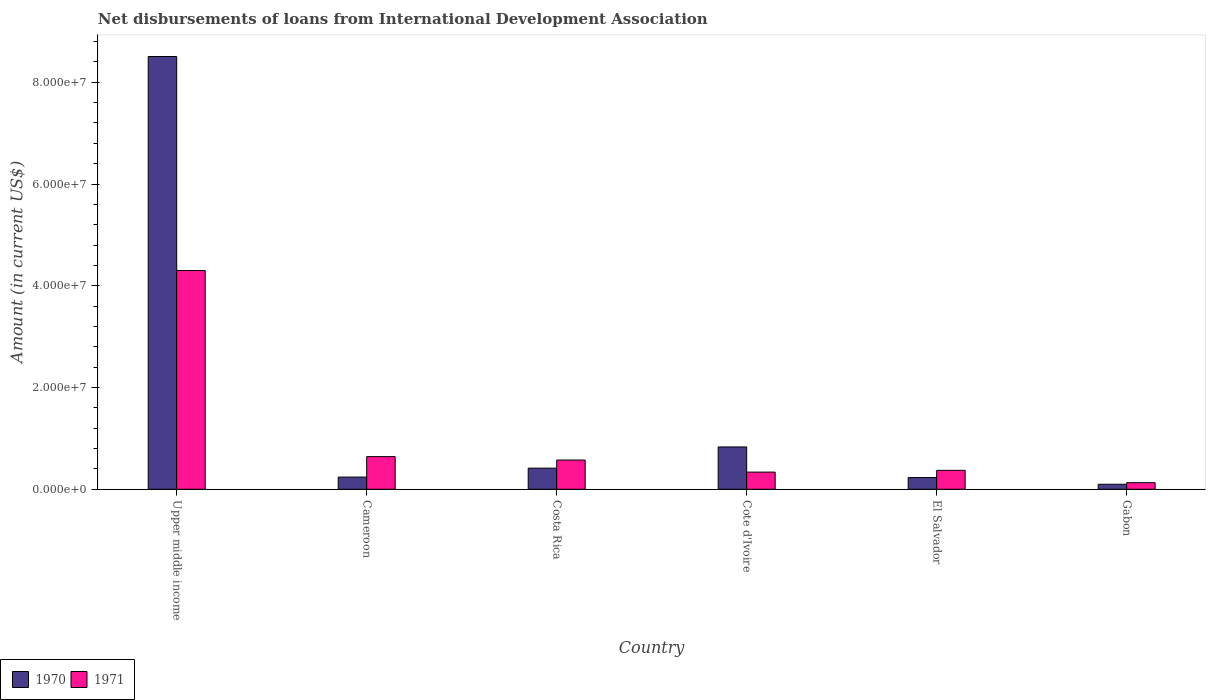How many groups of bars are there?
Provide a short and direct response. 6. Are the number of bars per tick equal to the number of legend labels?
Make the answer very short. Yes. Are the number of bars on each tick of the X-axis equal?
Give a very brief answer. Yes. How many bars are there on the 3rd tick from the left?
Keep it short and to the point. 2. How many bars are there on the 5th tick from the right?
Ensure brevity in your answer.  2. What is the label of the 5th group of bars from the left?
Ensure brevity in your answer.  El Salvador. In how many cases, is the number of bars for a given country not equal to the number of legend labels?
Provide a succinct answer. 0. What is the amount of loans disbursed in 1971 in Costa Rica?
Offer a terse response. 5.74e+06. Across all countries, what is the maximum amount of loans disbursed in 1970?
Your answer should be very brief. 8.51e+07. Across all countries, what is the minimum amount of loans disbursed in 1971?
Ensure brevity in your answer.  1.30e+06. In which country was the amount of loans disbursed in 1970 maximum?
Offer a terse response. Upper middle income. In which country was the amount of loans disbursed in 1970 minimum?
Give a very brief answer. Gabon. What is the total amount of loans disbursed in 1970 in the graph?
Your answer should be very brief. 1.03e+08. What is the difference between the amount of loans disbursed in 1971 in Cote d'Ivoire and that in El Salvador?
Ensure brevity in your answer.  -3.50e+05. What is the difference between the amount of loans disbursed in 1971 in Upper middle income and the amount of loans disbursed in 1970 in Gabon?
Offer a terse response. 4.20e+07. What is the average amount of loans disbursed in 1971 per country?
Provide a succinct answer. 1.06e+07. What is the difference between the amount of loans disbursed of/in 1970 and amount of loans disbursed of/in 1971 in Cote d'Ivoire?
Make the answer very short. 4.95e+06. In how many countries, is the amount of loans disbursed in 1970 greater than 76000000 US$?
Offer a very short reply. 1. What is the ratio of the amount of loans disbursed in 1971 in Costa Rica to that in Upper middle income?
Your response must be concise. 0.13. Is the amount of loans disbursed in 1970 in El Salvador less than that in Upper middle income?
Your response must be concise. Yes. Is the difference between the amount of loans disbursed in 1970 in Cote d'Ivoire and Upper middle income greater than the difference between the amount of loans disbursed in 1971 in Cote d'Ivoire and Upper middle income?
Your response must be concise. No. What is the difference between the highest and the second highest amount of loans disbursed in 1971?
Your answer should be very brief. 3.66e+07. What is the difference between the highest and the lowest amount of loans disbursed in 1970?
Your response must be concise. 8.41e+07. In how many countries, is the amount of loans disbursed in 1970 greater than the average amount of loans disbursed in 1970 taken over all countries?
Offer a very short reply. 1. Is the sum of the amount of loans disbursed in 1970 in Cote d'Ivoire and El Salvador greater than the maximum amount of loans disbursed in 1971 across all countries?
Make the answer very short. No. What does the 2nd bar from the left in Gabon represents?
Offer a very short reply. 1971. How many bars are there?
Your answer should be compact. 12. Are the values on the major ticks of Y-axis written in scientific E-notation?
Offer a terse response. Yes. Does the graph contain any zero values?
Give a very brief answer. No. Where does the legend appear in the graph?
Your response must be concise. Bottom left. What is the title of the graph?
Keep it short and to the point. Net disbursements of loans from International Development Association. What is the label or title of the Y-axis?
Provide a short and direct response. Amount (in current US$). What is the Amount (in current US$) of 1970 in Upper middle income?
Make the answer very short. 8.51e+07. What is the Amount (in current US$) in 1971 in Upper middle income?
Provide a succinct answer. 4.30e+07. What is the Amount (in current US$) in 1970 in Cameroon?
Make the answer very short. 2.40e+06. What is the Amount (in current US$) of 1971 in Cameroon?
Your answer should be very brief. 6.42e+06. What is the Amount (in current US$) of 1970 in Costa Rica?
Offer a very short reply. 4.15e+06. What is the Amount (in current US$) of 1971 in Costa Rica?
Your answer should be compact. 5.74e+06. What is the Amount (in current US$) of 1970 in Cote d'Ivoire?
Your response must be concise. 8.32e+06. What is the Amount (in current US$) in 1971 in Cote d'Ivoire?
Keep it short and to the point. 3.37e+06. What is the Amount (in current US$) in 1970 in El Salvador?
Make the answer very short. 2.30e+06. What is the Amount (in current US$) in 1971 in El Salvador?
Provide a short and direct response. 3.72e+06. What is the Amount (in current US$) in 1970 in Gabon?
Give a very brief answer. 9.85e+05. What is the Amount (in current US$) of 1971 in Gabon?
Make the answer very short. 1.30e+06. Across all countries, what is the maximum Amount (in current US$) of 1970?
Ensure brevity in your answer.  8.51e+07. Across all countries, what is the maximum Amount (in current US$) of 1971?
Make the answer very short. 4.30e+07. Across all countries, what is the minimum Amount (in current US$) in 1970?
Provide a short and direct response. 9.85e+05. Across all countries, what is the minimum Amount (in current US$) in 1971?
Give a very brief answer. 1.30e+06. What is the total Amount (in current US$) of 1970 in the graph?
Your answer should be compact. 1.03e+08. What is the total Amount (in current US$) of 1971 in the graph?
Make the answer very short. 6.36e+07. What is the difference between the Amount (in current US$) of 1970 in Upper middle income and that in Cameroon?
Your answer should be very brief. 8.27e+07. What is the difference between the Amount (in current US$) in 1971 in Upper middle income and that in Cameroon?
Keep it short and to the point. 3.66e+07. What is the difference between the Amount (in current US$) in 1970 in Upper middle income and that in Costa Rica?
Ensure brevity in your answer.  8.09e+07. What is the difference between the Amount (in current US$) in 1971 in Upper middle income and that in Costa Rica?
Offer a terse response. 3.73e+07. What is the difference between the Amount (in current US$) of 1970 in Upper middle income and that in Cote d'Ivoire?
Offer a terse response. 7.67e+07. What is the difference between the Amount (in current US$) in 1971 in Upper middle income and that in Cote d'Ivoire?
Ensure brevity in your answer.  3.96e+07. What is the difference between the Amount (in current US$) in 1970 in Upper middle income and that in El Salvador?
Provide a succinct answer. 8.28e+07. What is the difference between the Amount (in current US$) of 1971 in Upper middle income and that in El Salvador?
Offer a terse response. 3.93e+07. What is the difference between the Amount (in current US$) of 1970 in Upper middle income and that in Gabon?
Keep it short and to the point. 8.41e+07. What is the difference between the Amount (in current US$) of 1971 in Upper middle income and that in Gabon?
Ensure brevity in your answer.  4.17e+07. What is the difference between the Amount (in current US$) in 1970 in Cameroon and that in Costa Rica?
Keep it short and to the point. -1.76e+06. What is the difference between the Amount (in current US$) of 1971 in Cameroon and that in Costa Rica?
Provide a short and direct response. 6.75e+05. What is the difference between the Amount (in current US$) in 1970 in Cameroon and that in Cote d'Ivoire?
Ensure brevity in your answer.  -5.92e+06. What is the difference between the Amount (in current US$) of 1971 in Cameroon and that in Cote d'Ivoire?
Your answer should be very brief. 3.04e+06. What is the difference between the Amount (in current US$) of 1970 in Cameroon and that in El Salvador?
Your answer should be compact. 9.30e+04. What is the difference between the Amount (in current US$) of 1971 in Cameroon and that in El Salvador?
Make the answer very short. 2.70e+06. What is the difference between the Amount (in current US$) of 1970 in Cameroon and that in Gabon?
Keep it short and to the point. 1.41e+06. What is the difference between the Amount (in current US$) in 1971 in Cameroon and that in Gabon?
Offer a very short reply. 5.12e+06. What is the difference between the Amount (in current US$) in 1970 in Costa Rica and that in Cote d'Ivoire?
Ensure brevity in your answer.  -4.17e+06. What is the difference between the Amount (in current US$) in 1971 in Costa Rica and that in Cote d'Ivoire?
Your answer should be very brief. 2.37e+06. What is the difference between the Amount (in current US$) of 1970 in Costa Rica and that in El Salvador?
Offer a very short reply. 1.85e+06. What is the difference between the Amount (in current US$) in 1971 in Costa Rica and that in El Salvador?
Offer a terse response. 2.02e+06. What is the difference between the Amount (in current US$) in 1970 in Costa Rica and that in Gabon?
Provide a short and direct response. 3.17e+06. What is the difference between the Amount (in current US$) of 1971 in Costa Rica and that in Gabon?
Your answer should be compact. 4.45e+06. What is the difference between the Amount (in current US$) of 1970 in Cote d'Ivoire and that in El Salvador?
Provide a short and direct response. 6.02e+06. What is the difference between the Amount (in current US$) of 1971 in Cote d'Ivoire and that in El Salvador?
Keep it short and to the point. -3.50e+05. What is the difference between the Amount (in current US$) of 1970 in Cote d'Ivoire and that in Gabon?
Offer a terse response. 7.34e+06. What is the difference between the Amount (in current US$) in 1971 in Cote d'Ivoire and that in Gabon?
Keep it short and to the point. 2.08e+06. What is the difference between the Amount (in current US$) in 1970 in El Salvador and that in Gabon?
Make the answer very short. 1.32e+06. What is the difference between the Amount (in current US$) in 1971 in El Salvador and that in Gabon?
Keep it short and to the point. 2.43e+06. What is the difference between the Amount (in current US$) of 1970 in Upper middle income and the Amount (in current US$) of 1971 in Cameroon?
Make the answer very short. 7.86e+07. What is the difference between the Amount (in current US$) in 1970 in Upper middle income and the Amount (in current US$) in 1971 in Costa Rica?
Ensure brevity in your answer.  7.93e+07. What is the difference between the Amount (in current US$) in 1970 in Upper middle income and the Amount (in current US$) in 1971 in Cote d'Ivoire?
Your response must be concise. 8.17e+07. What is the difference between the Amount (in current US$) of 1970 in Upper middle income and the Amount (in current US$) of 1971 in El Salvador?
Your response must be concise. 8.13e+07. What is the difference between the Amount (in current US$) of 1970 in Upper middle income and the Amount (in current US$) of 1971 in Gabon?
Offer a very short reply. 8.38e+07. What is the difference between the Amount (in current US$) in 1970 in Cameroon and the Amount (in current US$) in 1971 in Costa Rica?
Your answer should be very brief. -3.35e+06. What is the difference between the Amount (in current US$) of 1970 in Cameroon and the Amount (in current US$) of 1971 in Cote d'Ivoire?
Offer a very short reply. -9.78e+05. What is the difference between the Amount (in current US$) in 1970 in Cameroon and the Amount (in current US$) in 1971 in El Salvador?
Offer a very short reply. -1.33e+06. What is the difference between the Amount (in current US$) in 1970 in Cameroon and the Amount (in current US$) in 1971 in Gabon?
Make the answer very short. 1.10e+06. What is the difference between the Amount (in current US$) in 1970 in Costa Rica and the Amount (in current US$) in 1971 in Cote d'Ivoire?
Offer a terse response. 7.79e+05. What is the difference between the Amount (in current US$) of 1970 in Costa Rica and the Amount (in current US$) of 1971 in El Salvador?
Make the answer very short. 4.29e+05. What is the difference between the Amount (in current US$) in 1970 in Costa Rica and the Amount (in current US$) in 1971 in Gabon?
Offer a very short reply. 2.86e+06. What is the difference between the Amount (in current US$) in 1970 in Cote d'Ivoire and the Amount (in current US$) in 1971 in El Salvador?
Offer a very short reply. 4.60e+06. What is the difference between the Amount (in current US$) of 1970 in Cote d'Ivoire and the Amount (in current US$) of 1971 in Gabon?
Give a very brief answer. 7.02e+06. What is the difference between the Amount (in current US$) of 1970 in El Salvador and the Amount (in current US$) of 1971 in Gabon?
Offer a terse response. 1.01e+06. What is the average Amount (in current US$) in 1970 per country?
Your answer should be very brief. 1.72e+07. What is the average Amount (in current US$) in 1971 per country?
Your answer should be compact. 1.06e+07. What is the difference between the Amount (in current US$) of 1970 and Amount (in current US$) of 1971 in Upper middle income?
Your answer should be compact. 4.21e+07. What is the difference between the Amount (in current US$) of 1970 and Amount (in current US$) of 1971 in Cameroon?
Offer a very short reply. -4.02e+06. What is the difference between the Amount (in current US$) in 1970 and Amount (in current US$) in 1971 in Costa Rica?
Offer a terse response. -1.59e+06. What is the difference between the Amount (in current US$) in 1970 and Amount (in current US$) in 1971 in Cote d'Ivoire?
Offer a terse response. 4.95e+06. What is the difference between the Amount (in current US$) of 1970 and Amount (in current US$) of 1971 in El Salvador?
Your answer should be very brief. -1.42e+06. What is the difference between the Amount (in current US$) of 1970 and Amount (in current US$) of 1971 in Gabon?
Your response must be concise. -3.11e+05. What is the ratio of the Amount (in current US$) in 1970 in Upper middle income to that in Cameroon?
Your response must be concise. 35.5. What is the ratio of the Amount (in current US$) in 1971 in Upper middle income to that in Cameroon?
Provide a succinct answer. 6.7. What is the ratio of the Amount (in current US$) in 1970 in Upper middle income to that in Costa Rica?
Offer a very short reply. 20.48. What is the ratio of the Amount (in current US$) in 1971 in Upper middle income to that in Costa Rica?
Ensure brevity in your answer.  7.49. What is the ratio of the Amount (in current US$) in 1970 in Upper middle income to that in Cote d'Ivoire?
Offer a terse response. 10.22. What is the ratio of the Amount (in current US$) in 1971 in Upper middle income to that in Cote d'Ivoire?
Provide a succinct answer. 12.74. What is the ratio of the Amount (in current US$) of 1970 in Upper middle income to that in El Salvador?
Give a very brief answer. 36.94. What is the ratio of the Amount (in current US$) of 1971 in Upper middle income to that in El Salvador?
Your answer should be compact. 11.55. What is the ratio of the Amount (in current US$) in 1970 in Upper middle income to that in Gabon?
Keep it short and to the point. 86.36. What is the ratio of the Amount (in current US$) in 1971 in Upper middle income to that in Gabon?
Your response must be concise. 33.18. What is the ratio of the Amount (in current US$) in 1970 in Cameroon to that in Costa Rica?
Keep it short and to the point. 0.58. What is the ratio of the Amount (in current US$) of 1971 in Cameroon to that in Costa Rica?
Your answer should be very brief. 1.12. What is the ratio of the Amount (in current US$) of 1970 in Cameroon to that in Cote d'Ivoire?
Your response must be concise. 0.29. What is the ratio of the Amount (in current US$) in 1971 in Cameroon to that in Cote d'Ivoire?
Offer a terse response. 1.9. What is the ratio of the Amount (in current US$) of 1970 in Cameroon to that in El Salvador?
Provide a short and direct response. 1.04. What is the ratio of the Amount (in current US$) of 1971 in Cameroon to that in El Salvador?
Make the answer very short. 1.72. What is the ratio of the Amount (in current US$) of 1970 in Cameroon to that in Gabon?
Your answer should be compact. 2.43. What is the ratio of the Amount (in current US$) of 1971 in Cameroon to that in Gabon?
Make the answer very short. 4.95. What is the ratio of the Amount (in current US$) in 1970 in Costa Rica to that in Cote d'Ivoire?
Give a very brief answer. 0.5. What is the ratio of the Amount (in current US$) in 1971 in Costa Rica to that in Cote d'Ivoire?
Your answer should be very brief. 1.7. What is the ratio of the Amount (in current US$) of 1970 in Costa Rica to that in El Salvador?
Your answer should be very brief. 1.8. What is the ratio of the Amount (in current US$) in 1971 in Costa Rica to that in El Salvador?
Keep it short and to the point. 1.54. What is the ratio of the Amount (in current US$) of 1970 in Costa Rica to that in Gabon?
Make the answer very short. 4.22. What is the ratio of the Amount (in current US$) in 1971 in Costa Rica to that in Gabon?
Offer a terse response. 4.43. What is the ratio of the Amount (in current US$) of 1970 in Cote d'Ivoire to that in El Salvador?
Your answer should be compact. 3.61. What is the ratio of the Amount (in current US$) of 1971 in Cote d'Ivoire to that in El Salvador?
Offer a terse response. 0.91. What is the ratio of the Amount (in current US$) in 1970 in Cote d'Ivoire to that in Gabon?
Your response must be concise. 8.45. What is the ratio of the Amount (in current US$) in 1971 in Cote d'Ivoire to that in Gabon?
Provide a short and direct response. 2.6. What is the ratio of the Amount (in current US$) of 1970 in El Salvador to that in Gabon?
Keep it short and to the point. 2.34. What is the ratio of the Amount (in current US$) of 1971 in El Salvador to that in Gabon?
Provide a succinct answer. 2.87. What is the difference between the highest and the second highest Amount (in current US$) in 1970?
Keep it short and to the point. 7.67e+07. What is the difference between the highest and the second highest Amount (in current US$) in 1971?
Offer a terse response. 3.66e+07. What is the difference between the highest and the lowest Amount (in current US$) in 1970?
Provide a succinct answer. 8.41e+07. What is the difference between the highest and the lowest Amount (in current US$) in 1971?
Keep it short and to the point. 4.17e+07. 